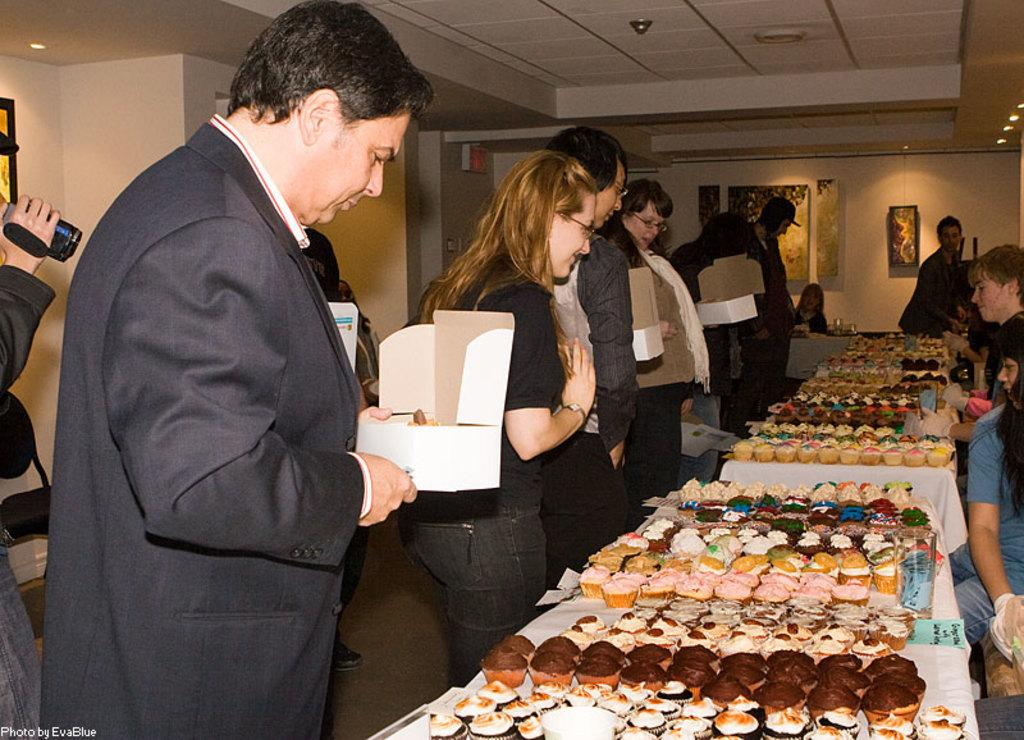What is happening in the image? There are persons standing in the image, and they are staring at cupcakes. Where are the cupcakes located? The cupcakes are placed on a table. What type of cap is the person wearing in the image? There is no cap visible in the image; the persons are not wearing any headwear. What verse is being recited by the person in the image? There is no verse being recited in the image; the persons are simply staring at the cupcakes. 